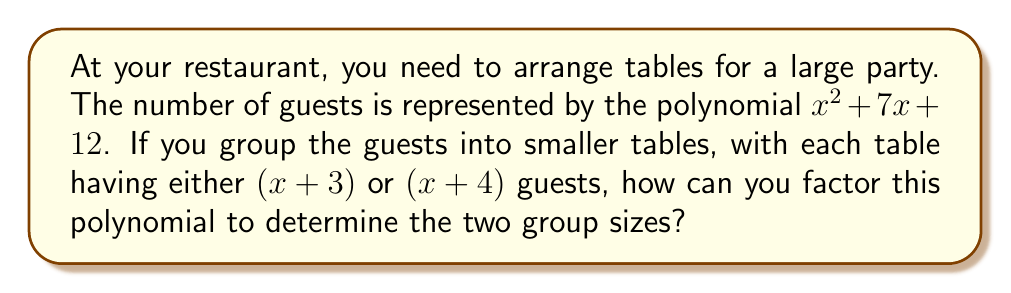What is the answer to this math problem? Let's factor the polynomial $x^2 + 7x + 12$ step by step:

1) First, we need to find two numbers that multiply to give 12 (the constant term) and add up to 7 (the coefficient of x).

2) These numbers are 3 and 4, because $3 \times 4 = 12$ and $3 + 4 = 7$.

3) We can rewrite the middle term using these numbers:
   $$x^2 + 7x + 12 = x^2 + 3x + 4x + 12$$

4) Now we can group the terms:
   $$(x^2 + 3x) + (4x + 12)$$

5) Factor out the common factors from each group:
   $$x(x + 3) + 4(x + 3)$$

6) We can see that $(x + 3)$ is common to both terms, so we can factor it out:
   $$(x + 3)(x + 4)$$

This factorization shows that the guests can be arranged into two groups: one with $(x + 3)$ guests and another with $(x + 4)$ guests.
Answer: $(x + 3)(x + 4)$ 